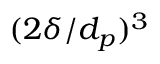<formula> <loc_0><loc_0><loc_500><loc_500>( 2 \delta / d _ { p } ) ^ { 3 }</formula> 